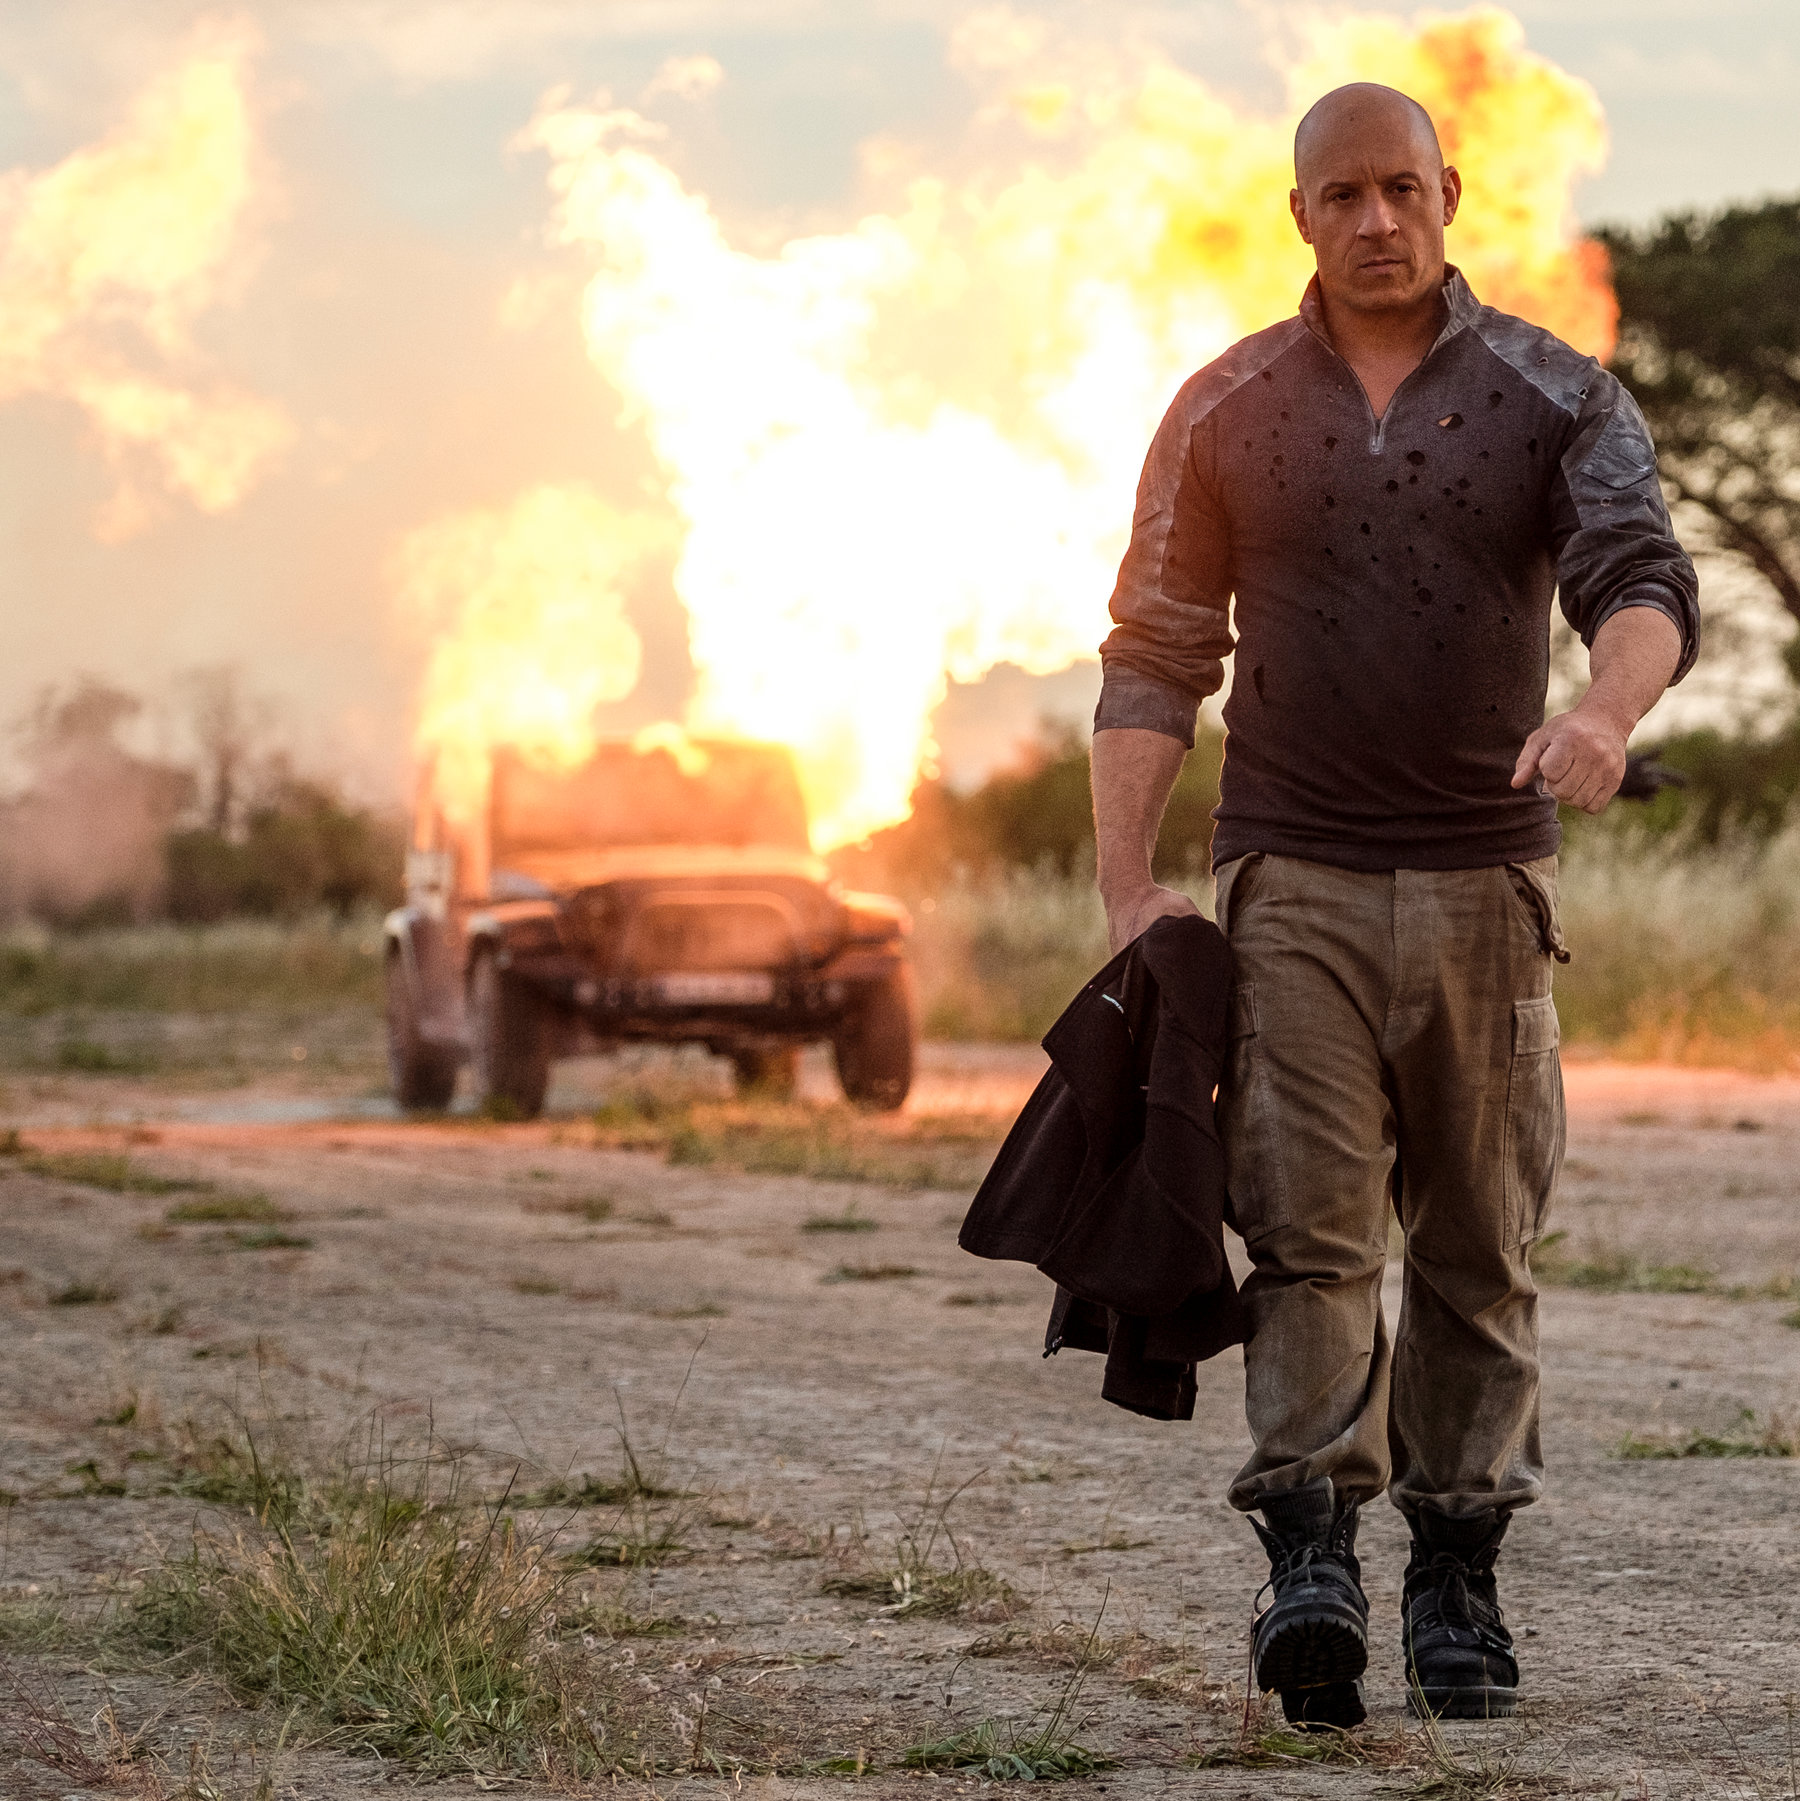What's happening in the scene? In the image, a man is depicted walking away from an intense explosion. He appears composed despite the large flames erupting behind him from a parked vehicle. He is wearing a speckled gray shirt, beige pants, and carries a black jacket in his left hand. The explosion paints the sky in dramatic hues of orange and red, suggesting the scene might be occurring at sunset. This contrast highlights the calm demeanor of the man against the chaotic background. 